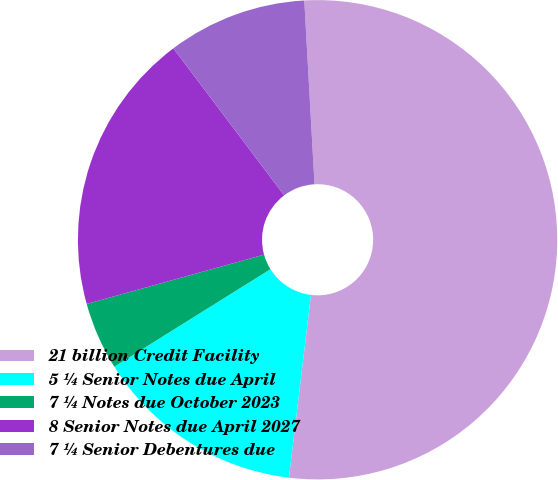Convert chart to OTSL. <chart><loc_0><loc_0><loc_500><loc_500><pie_chart><fcel>21 billion Credit Facility<fcel>5 ¼ Senior Notes due April<fcel>7 ¼ Notes due October 2023<fcel>8 Senior Notes due April 2027<fcel>7 ¼ Senior Debentures due<nl><fcel>52.79%<fcel>14.21%<fcel>4.57%<fcel>19.04%<fcel>9.39%<nl></chart> 